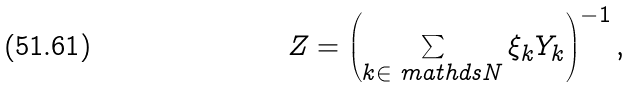<formula> <loc_0><loc_0><loc_500><loc_500>Z = \left ( \sum _ { k \in \ m a t h d s { N } } \xi _ { k } Y _ { k } \right ) ^ { - 1 } ,</formula> 